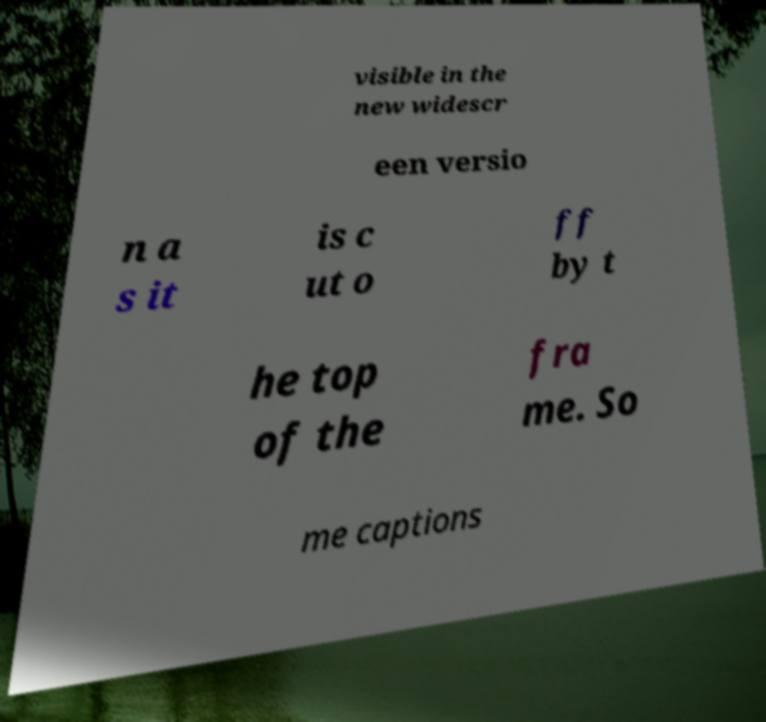Can you read and provide the text displayed in the image?This photo seems to have some interesting text. Can you extract and type it out for me? visible in the new widescr een versio n a s it is c ut o ff by t he top of the fra me. So me captions 